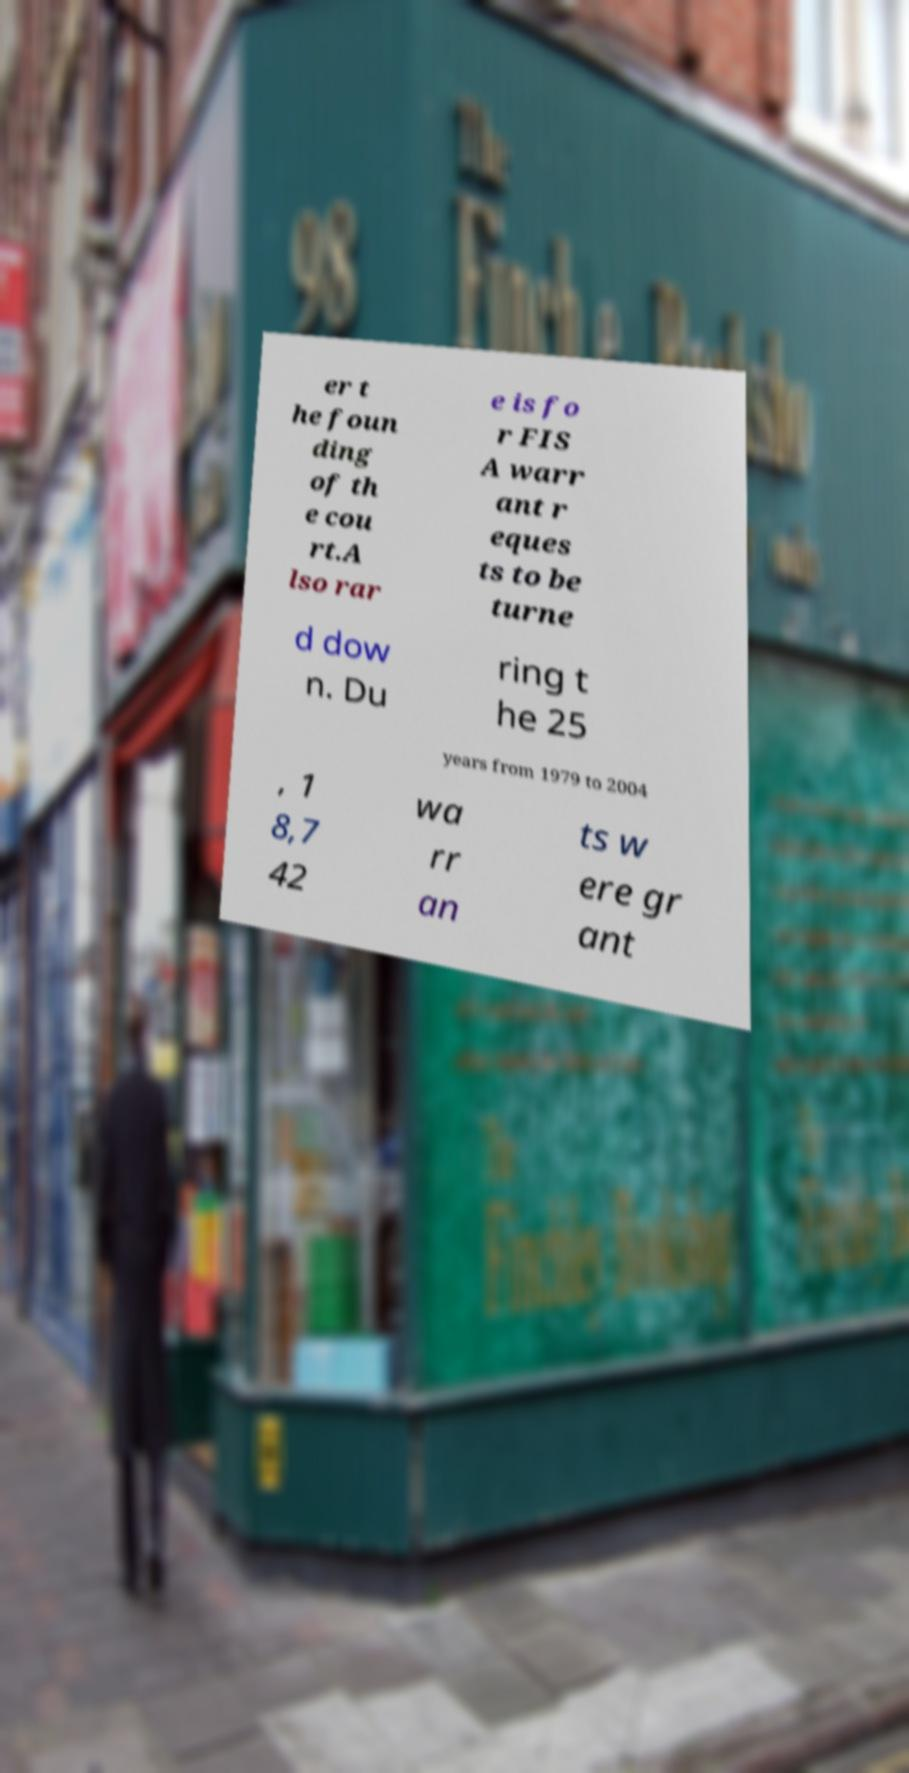Could you assist in decoding the text presented in this image and type it out clearly? er t he foun ding of th e cou rt.A lso rar e is fo r FIS A warr ant r eques ts to be turne d dow n. Du ring t he 25 years from 1979 to 2004 , 1 8,7 42 wa rr an ts w ere gr ant 